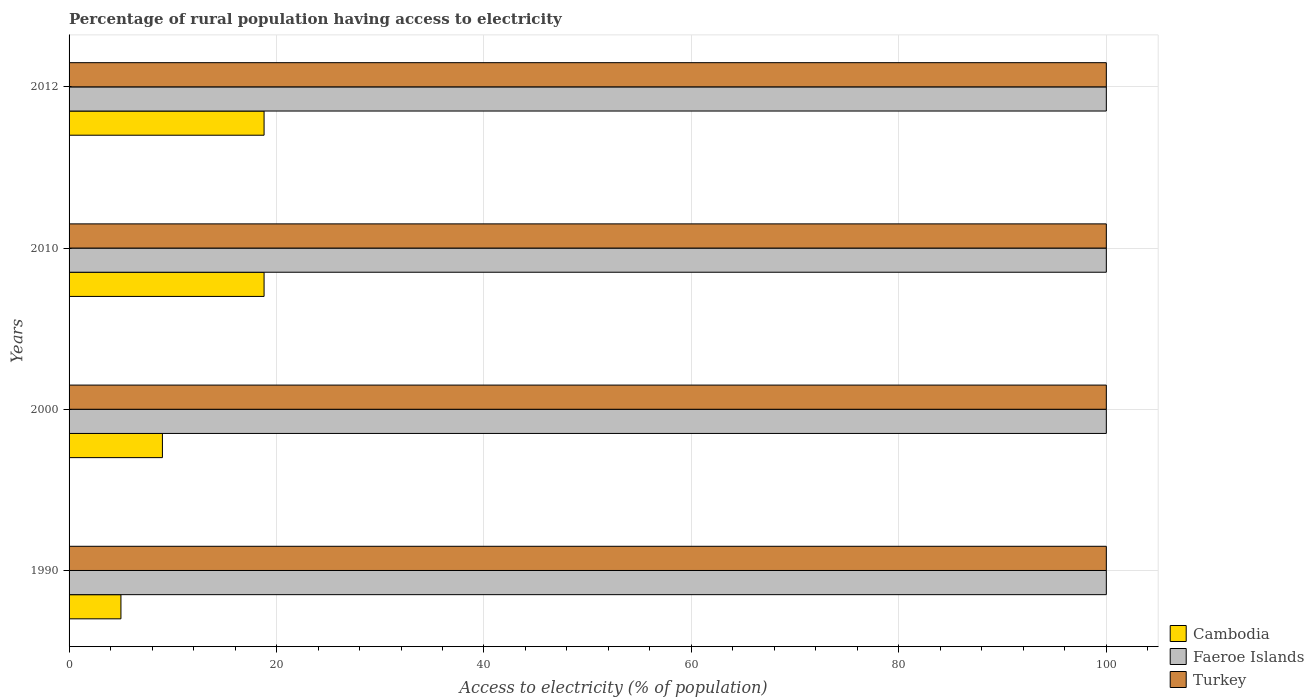How many different coloured bars are there?
Offer a terse response. 3. How many groups of bars are there?
Your answer should be very brief. 4. Are the number of bars per tick equal to the number of legend labels?
Ensure brevity in your answer.  Yes. Are the number of bars on each tick of the Y-axis equal?
Your response must be concise. Yes. How many bars are there on the 4th tick from the bottom?
Ensure brevity in your answer.  3. What is the percentage of rural population having access to electricity in Faeroe Islands in 1990?
Make the answer very short. 100. Across all years, what is the maximum percentage of rural population having access to electricity in Faeroe Islands?
Give a very brief answer. 100. Across all years, what is the minimum percentage of rural population having access to electricity in Cambodia?
Your answer should be very brief. 5. In which year was the percentage of rural population having access to electricity in Cambodia maximum?
Provide a succinct answer. 2010. In which year was the percentage of rural population having access to electricity in Turkey minimum?
Make the answer very short. 1990. What is the total percentage of rural population having access to electricity in Faeroe Islands in the graph?
Provide a succinct answer. 400. What is the difference between the percentage of rural population having access to electricity in Cambodia in 1990 and the percentage of rural population having access to electricity in Turkey in 2010?
Your response must be concise. -95. In the year 2000, what is the difference between the percentage of rural population having access to electricity in Turkey and percentage of rural population having access to electricity in Cambodia?
Provide a short and direct response. 91. In how many years, is the percentage of rural population having access to electricity in Faeroe Islands greater than 48 %?
Provide a short and direct response. 4. What is the ratio of the percentage of rural population having access to electricity in Turkey in 2000 to that in 2010?
Make the answer very short. 1. Is the percentage of rural population having access to electricity in Cambodia in 2000 less than that in 2010?
Offer a terse response. Yes. Is the difference between the percentage of rural population having access to electricity in Turkey in 2000 and 2010 greater than the difference between the percentage of rural population having access to electricity in Cambodia in 2000 and 2010?
Make the answer very short. Yes. Is the sum of the percentage of rural population having access to electricity in Faeroe Islands in 1990 and 2000 greater than the maximum percentage of rural population having access to electricity in Turkey across all years?
Give a very brief answer. Yes. What does the 1st bar from the top in 2012 represents?
Provide a short and direct response. Turkey. What does the 2nd bar from the bottom in 1990 represents?
Your response must be concise. Faeroe Islands. Is it the case that in every year, the sum of the percentage of rural population having access to electricity in Turkey and percentage of rural population having access to electricity in Faeroe Islands is greater than the percentage of rural population having access to electricity in Cambodia?
Make the answer very short. Yes. Are all the bars in the graph horizontal?
Provide a short and direct response. Yes. What is the difference between two consecutive major ticks on the X-axis?
Your answer should be compact. 20. Does the graph contain any zero values?
Your answer should be compact. No. Does the graph contain grids?
Make the answer very short. Yes. Where does the legend appear in the graph?
Your answer should be very brief. Bottom right. How are the legend labels stacked?
Offer a very short reply. Vertical. What is the title of the graph?
Offer a very short reply. Percentage of rural population having access to electricity. Does "Azerbaijan" appear as one of the legend labels in the graph?
Offer a terse response. No. What is the label or title of the X-axis?
Provide a short and direct response. Access to electricity (% of population). What is the label or title of the Y-axis?
Ensure brevity in your answer.  Years. What is the Access to electricity (% of population) in Turkey in 1990?
Make the answer very short. 100. What is the Access to electricity (% of population) in Cambodia in 2000?
Provide a succinct answer. 9. What is the Access to electricity (% of population) of Faeroe Islands in 2000?
Offer a terse response. 100. What is the Access to electricity (% of population) in Cambodia in 2010?
Keep it short and to the point. 18.8. What is the Access to electricity (% of population) in Faeroe Islands in 2010?
Keep it short and to the point. 100. What is the Access to electricity (% of population) in Faeroe Islands in 2012?
Provide a short and direct response. 100. What is the Access to electricity (% of population) of Turkey in 2012?
Make the answer very short. 100. Across all years, what is the maximum Access to electricity (% of population) in Cambodia?
Make the answer very short. 18.8. Across all years, what is the maximum Access to electricity (% of population) in Faeroe Islands?
Give a very brief answer. 100. Across all years, what is the minimum Access to electricity (% of population) in Faeroe Islands?
Offer a terse response. 100. Across all years, what is the minimum Access to electricity (% of population) of Turkey?
Offer a very short reply. 100. What is the total Access to electricity (% of population) of Cambodia in the graph?
Your answer should be very brief. 51.6. What is the total Access to electricity (% of population) of Faeroe Islands in the graph?
Provide a succinct answer. 400. What is the total Access to electricity (% of population) in Turkey in the graph?
Provide a succinct answer. 400. What is the difference between the Access to electricity (% of population) in Cambodia in 1990 and that in 2000?
Give a very brief answer. -4. What is the difference between the Access to electricity (% of population) in Turkey in 1990 and that in 2000?
Keep it short and to the point. 0. What is the difference between the Access to electricity (% of population) in Turkey in 1990 and that in 2010?
Give a very brief answer. 0. What is the difference between the Access to electricity (% of population) of Cambodia in 1990 and that in 2012?
Your answer should be very brief. -13.8. What is the difference between the Access to electricity (% of population) of Cambodia in 2000 and that in 2010?
Keep it short and to the point. -9.8. What is the difference between the Access to electricity (% of population) in Cambodia in 2000 and that in 2012?
Provide a succinct answer. -9.8. What is the difference between the Access to electricity (% of population) in Cambodia in 1990 and the Access to electricity (% of population) in Faeroe Islands in 2000?
Make the answer very short. -95. What is the difference between the Access to electricity (% of population) of Cambodia in 1990 and the Access to electricity (% of population) of Turkey in 2000?
Provide a succinct answer. -95. What is the difference between the Access to electricity (% of population) in Cambodia in 1990 and the Access to electricity (% of population) in Faeroe Islands in 2010?
Make the answer very short. -95. What is the difference between the Access to electricity (% of population) of Cambodia in 1990 and the Access to electricity (% of population) of Turkey in 2010?
Your response must be concise. -95. What is the difference between the Access to electricity (% of population) in Cambodia in 1990 and the Access to electricity (% of population) in Faeroe Islands in 2012?
Offer a terse response. -95. What is the difference between the Access to electricity (% of population) of Cambodia in 1990 and the Access to electricity (% of population) of Turkey in 2012?
Your response must be concise. -95. What is the difference between the Access to electricity (% of population) of Cambodia in 2000 and the Access to electricity (% of population) of Faeroe Islands in 2010?
Your answer should be compact. -91. What is the difference between the Access to electricity (% of population) in Cambodia in 2000 and the Access to electricity (% of population) in Turkey in 2010?
Offer a terse response. -91. What is the difference between the Access to electricity (% of population) in Cambodia in 2000 and the Access to electricity (% of population) in Faeroe Islands in 2012?
Make the answer very short. -91. What is the difference between the Access to electricity (% of population) of Cambodia in 2000 and the Access to electricity (% of population) of Turkey in 2012?
Offer a terse response. -91. What is the difference between the Access to electricity (% of population) of Faeroe Islands in 2000 and the Access to electricity (% of population) of Turkey in 2012?
Your answer should be compact. 0. What is the difference between the Access to electricity (% of population) of Cambodia in 2010 and the Access to electricity (% of population) of Faeroe Islands in 2012?
Give a very brief answer. -81.2. What is the difference between the Access to electricity (% of population) in Cambodia in 2010 and the Access to electricity (% of population) in Turkey in 2012?
Keep it short and to the point. -81.2. What is the average Access to electricity (% of population) in Faeroe Islands per year?
Your answer should be compact. 100. What is the average Access to electricity (% of population) in Turkey per year?
Your answer should be very brief. 100. In the year 1990, what is the difference between the Access to electricity (% of population) of Cambodia and Access to electricity (% of population) of Faeroe Islands?
Give a very brief answer. -95. In the year 1990, what is the difference between the Access to electricity (% of population) in Cambodia and Access to electricity (% of population) in Turkey?
Your answer should be very brief. -95. In the year 1990, what is the difference between the Access to electricity (% of population) in Faeroe Islands and Access to electricity (% of population) in Turkey?
Ensure brevity in your answer.  0. In the year 2000, what is the difference between the Access to electricity (% of population) in Cambodia and Access to electricity (% of population) in Faeroe Islands?
Provide a short and direct response. -91. In the year 2000, what is the difference between the Access to electricity (% of population) of Cambodia and Access to electricity (% of population) of Turkey?
Keep it short and to the point. -91. In the year 2010, what is the difference between the Access to electricity (% of population) of Cambodia and Access to electricity (% of population) of Faeroe Islands?
Make the answer very short. -81.2. In the year 2010, what is the difference between the Access to electricity (% of population) in Cambodia and Access to electricity (% of population) in Turkey?
Provide a succinct answer. -81.2. In the year 2012, what is the difference between the Access to electricity (% of population) of Cambodia and Access to electricity (% of population) of Faeroe Islands?
Make the answer very short. -81.2. In the year 2012, what is the difference between the Access to electricity (% of population) of Cambodia and Access to electricity (% of population) of Turkey?
Keep it short and to the point. -81.2. What is the ratio of the Access to electricity (% of population) of Cambodia in 1990 to that in 2000?
Your answer should be very brief. 0.56. What is the ratio of the Access to electricity (% of population) of Faeroe Islands in 1990 to that in 2000?
Provide a short and direct response. 1. What is the ratio of the Access to electricity (% of population) of Turkey in 1990 to that in 2000?
Your answer should be compact. 1. What is the ratio of the Access to electricity (% of population) of Cambodia in 1990 to that in 2010?
Keep it short and to the point. 0.27. What is the ratio of the Access to electricity (% of population) of Faeroe Islands in 1990 to that in 2010?
Provide a short and direct response. 1. What is the ratio of the Access to electricity (% of population) in Turkey in 1990 to that in 2010?
Offer a terse response. 1. What is the ratio of the Access to electricity (% of population) in Cambodia in 1990 to that in 2012?
Offer a terse response. 0.27. What is the ratio of the Access to electricity (% of population) in Faeroe Islands in 1990 to that in 2012?
Your answer should be very brief. 1. What is the ratio of the Access to electricity (% of population) of Turkey in 1990 to that in 2012?
Offer a very short reply. 1. What is the ratio of the Access to electricity (% of population) in Cambodia in 2000 to that in 2010?
Ensure brevity in your answer.  0.48. What is the ratio of the Access to electricity (% of population) in Faeroe Islands in 2000 to that in 2010?
Provide a succinct answer. 1. What is the ratio of the Access to electricity (% of population) of Cambodia in 2000 to that in 2012?
Your answer should be compact. 0.48. What is the ratio of the Access to electricity (% of population) in Faeroe Islands in 2000 to that in 2012?
Provide a short and direct response. 1. What is the ratio of the Access to electricity (% of population) of Cambodia in 2010 to that in 2012?
Offer a very short reply. 1. What is the ratio of the Access to electricity (% of population) in Faeroe Islands in 2010 to that in 2012?
Provide a short and direct response. 1. What is the ratio of the Access to electricity (% of population) of Turkey in 2010 to that in 2012?
Make the answer very short. 1. What is the difference between the highest and the second highest Access to electricity (% of population) in Faeroe Islands?
Provide a succinct answer. 0. What is the difference between the highest and the second highest Access to electricity (% of population) of Turkey?
Offer a very short reply. 0. What is the difference between the highest and the lowest Access to electricity (% of population) of Faeroe Islands?
Provide a short and direct response. 0. 